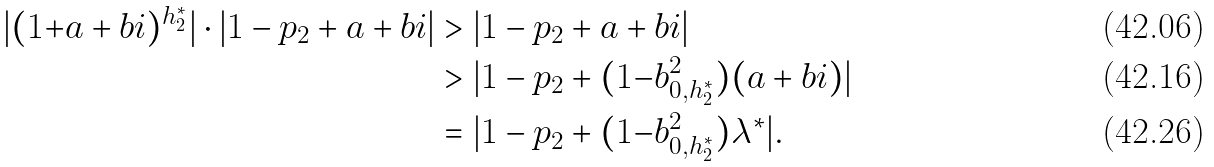Convert formula to latex. <formula><loc_0><loc_0><loc_500><loc_500>| ( 1 { + } a + b i ) ^ { h ^ { * } _ { 2 } } | \cdot | 1 - p _ { 2 } + a + b i | & > | 1 - p _ { 2 } + a + b i | \\ & > | 1 - p _ { 2 } + ( 1 { - } b _ { 0 , h ^ { * } _ { 2 } } ^ { 2 } ) ( a + b i ) | \\ & = | 1 - p _ { 2 } + ( 1 { - } b _ { 0 , h ^ { * } _ { 2 } } ^ { 2 } ) \lambda ^ { * } | .</formula> 